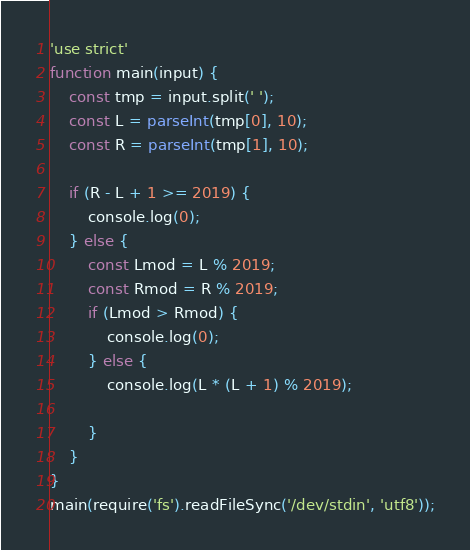Convert code to text. <code><loc_0><loc_0><loc_500><loc_500><_JavaScript_>'use strict'
function main(input) {
    const tmp = input.split(' ');
    const L = parseInt(tmp[0], 10);
    const R = parseInt(tmp[1], 10);

    if (R - L + 1 >= 2019) {
        console.log(0);
    } else {
        const Lmod = L % 2019;
        const Rmod = R % 2019;
        if (Lmod > Rmod) {
            console.log(0);
        } else {
            console.log(L * (L + 1) % 2019);

        }
    }
}
main(require('fs').readFileSync('/dev/stdin', 'utf8'));</code> 